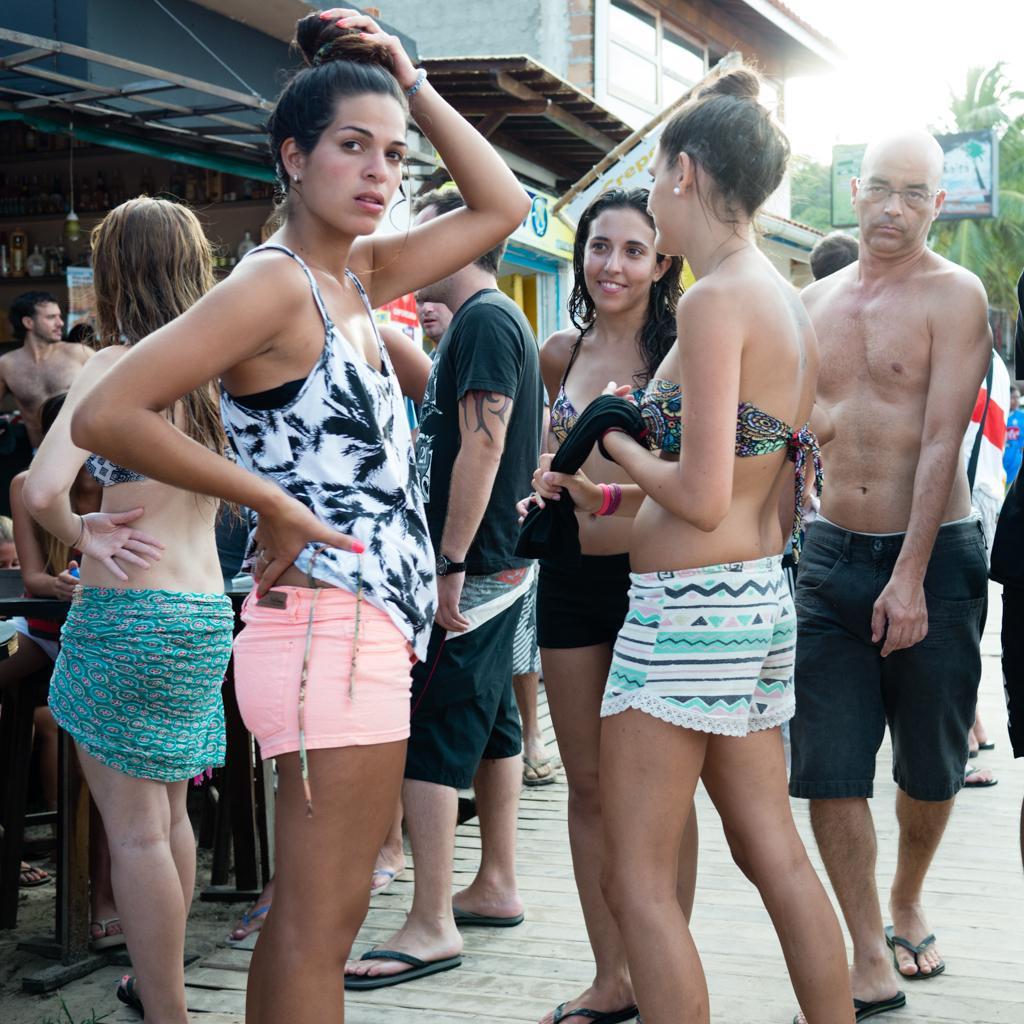Can you describe this image briefly? In this image there are some persons standing at middle of this image and there is a building in the background. There is a tree at right side of this image. The women standing in middle of this image is wearing white color top and cream color short and the right side person is wearing black color t shirt and black color short and wearing a slippers and the right side person is wearing a white color short and holding one cloth which is in black color. There are some chairs at left side of this image. 